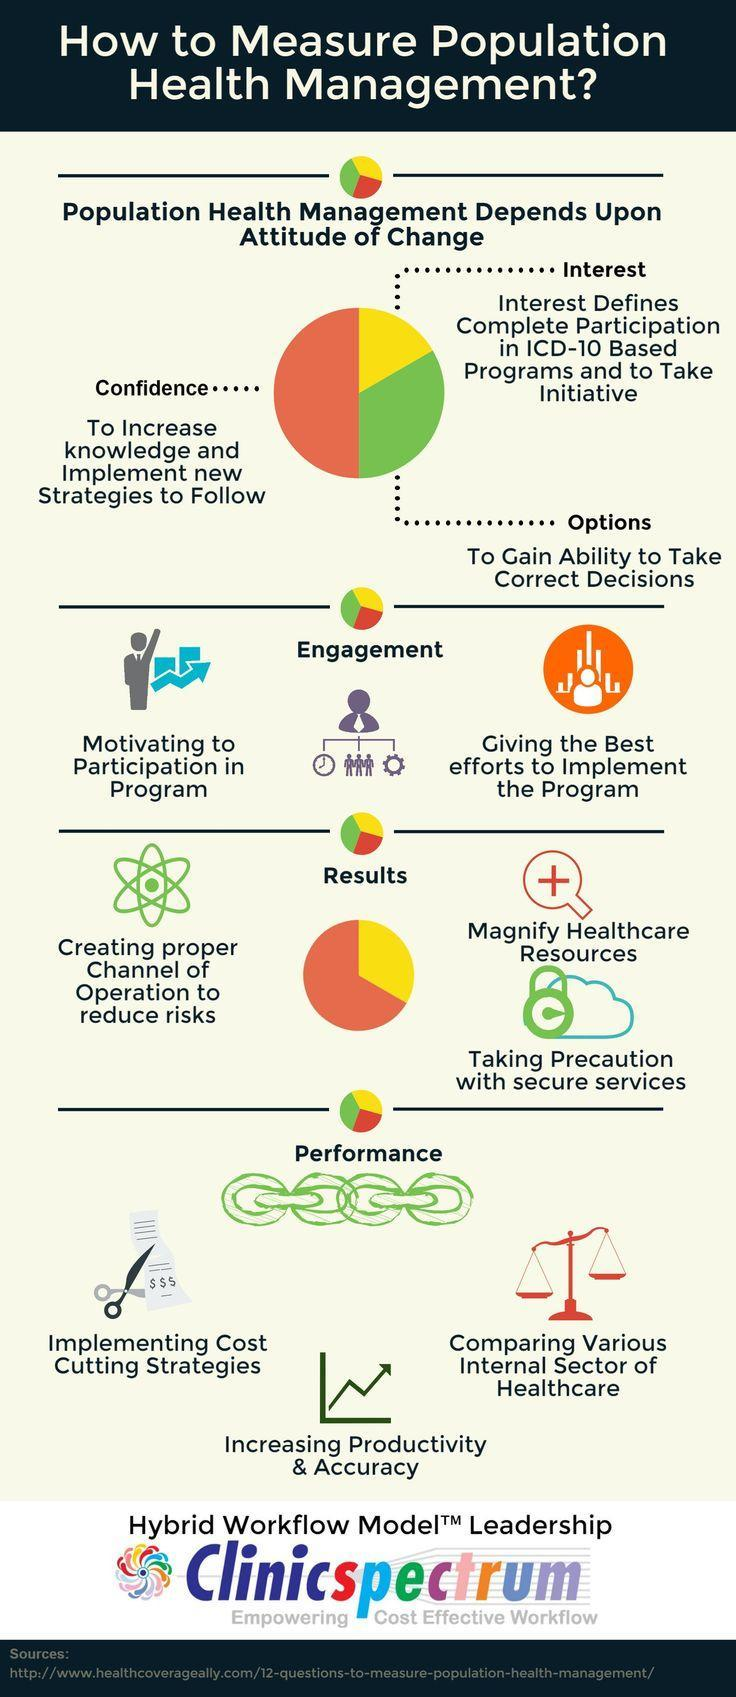Which aspect of attitude of change contributes to 50% percentage of population health management?
Answer the question with a short phrase. Confidence 